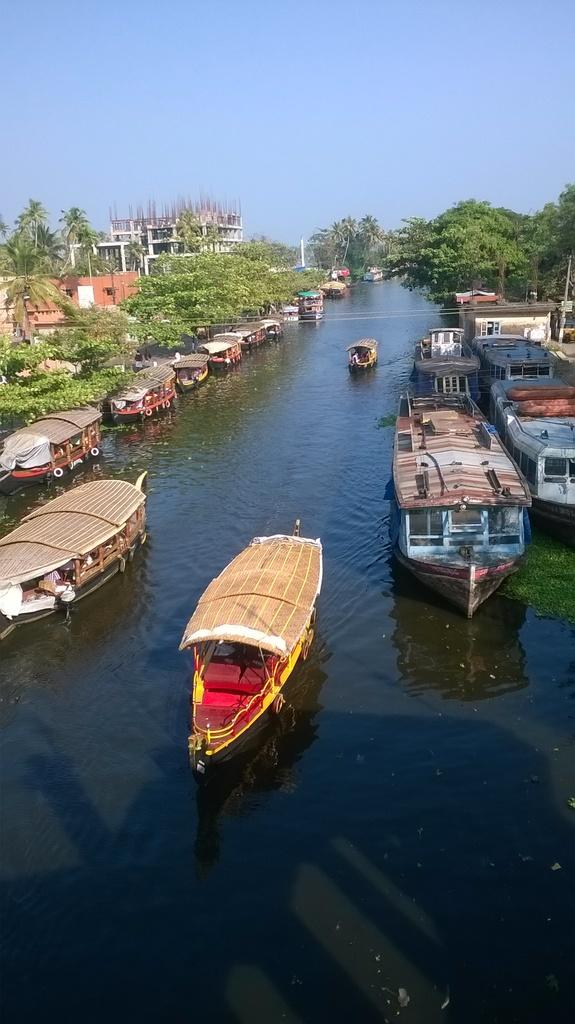What is in the water in the image? There are boats in the water in the image. What can be seen in the background of the image? There are trees, buildings, and poles in the background of the image. What is visible at the top of the image? The sky is visible at the top of the image. What type of scissors can be seen cutting the trees in the background? There are no scissors present in the image, and the trees are not being cut. How many clouds are visible in the sky in the image? The provided facts do not mention any clouds in the sky, so we cannot determine the number of clouds visible. 